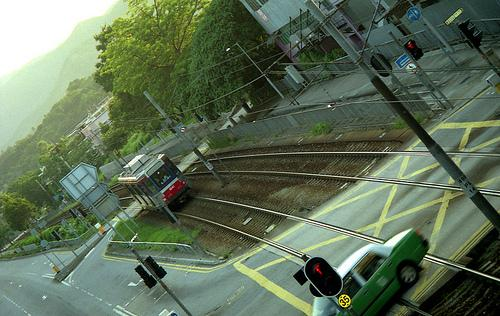In the image, is there an instance where a vehicle can be seen crossing the train tracks? If so, describe it. Yes, a green car is driving over the train tracks at the intersection, where yellow markings are visible. Describe any peculiar elements or instances that stand out within the image. A green car driving over the yellow markings on the train tracks and the red light being illuminated are peculiar instances. Analyze the types of traffic control devices (e.g. signs, signals, etc.) present in the image. Stop sign, walkway sign, yellow street markings, white arrows, red traffic light, and speed limit sign displaying 35. Describe the most prominent natural elements visible in the image. The green mountain range and trees in the background are the most prominent natural elements. In a few words, describe how the scene in the image feels. Busy, with various modes of transportation and street elements interacting. List any object or person(s) seen interacting with the train in the image. A green car that's crossing the train tracks is interacting with the train. What is the main mode of transportation in the image? The main mode of transportation is a tram. Identify and describe the signs that can be seen on the street in the image. There is a stop sign, a walkway sign, a speed limit sign showing 35, and a yellow sign with white arrows painted on the street. What color are the trees in the image and where are they located? The trees are green and located in the background. Count and describe the total number of train cars and their colors. There is one red, white, and gray train car on the tracks. Does the tram car have the words "public transportation" written on it? The tram car is described as being part of public transportation, but there is no mention of the words "public transportation" explicitly being written on the tram car. Is the train car on the tracks green and yellow? The train car is described as "red, white, and gray/blue" and "red, white, and blue", but nowhere is it mentioned as green and yellow. A green car is mentioned, but it is not the train car. Is the speed limit sign showing a limit of 50? The speed limit sign is mentioned as having the number 35 on it, not 50. There is no mention of any sign showing a speed limit of 50. Are the yellow lines on the street vertical and parallel? No, it's not mentioned in the image. Is there a blue mountain range behind the trees? The mountain range mentioned is described as green, not blue. There is no mention of a blue mountain range in the image. Is the stop sign signaling green instead of red?  The stop sign is described as signaling red, not green. There is no mention of a green stop sign. 